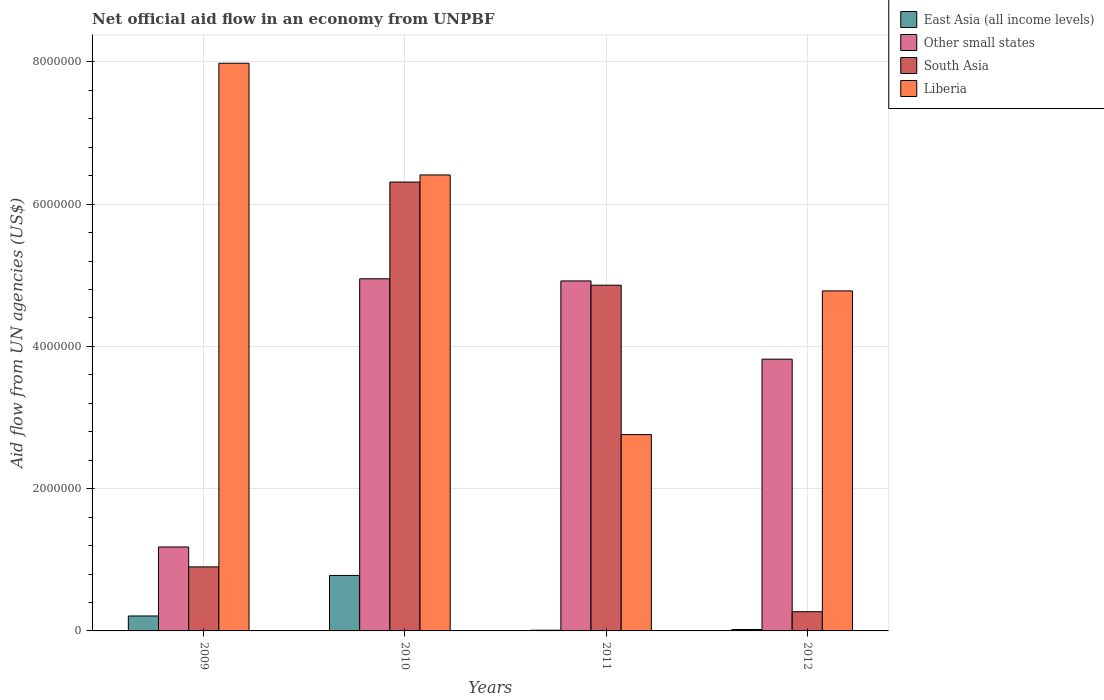How many bars are there on the 2nd tick from the left?
Keep it short and to the point. 4. What is the label of the 2nd group of bars from the left?
Give a very brief answer. 2010. In how many cases, is the number of bars for a given year not equal to the number of legend labels?
Provide a succinct answer. 0. What is the net official aid flow in Liberia in 2009?
Your answer should be compact. 7.98e+06. Across all years, what is the maximum net official aid flow in South Asia?
Keep it short and to the point. 6.31e+06. Across all years, what is the minimum net official aid flow in East Asia (all income levels)?
Your answer should be very brief. 10000. In which year was the net official aid flow in East Asia (all income levels) maximum?
Your answer should be compact. 2010. What is the total net official aid flow in East Asia (all income levels) in the graph?
Provide a short and direct response. 1.02e+06. What is the difference between the net official aid flow in Other small states in 2010 and that in 2012?
Your answer should be compact. 1.13e+06. What is the difference between the net official aid flow in East Asia (all income levels) in 2011 and the net official aid flow in Liberia in 2009?
Provide a short and direct response. -7.97e+06. What is the average net official aid flow in South Asia per year?
Your answer should be very brief. 3.08e+06. In the year 2010, what is the difference between the net official aid flow in East Asia (all income levels) and net official aid flow in Liberia?
Offer a very short reply. -5.63e+06. What is the ratio of the net official aid flow in Liberia in 2010 to that in 2012?
Your answer should be compact. 1.34. Is the net official aid flow in South Asia in 2011 less than that in 2012?
Offer a very short reply. No. What is the difference between the highest and the second highest net official aid flow in South Asia?
Your answer should be compact. 1.45e+06. What is the difference between the highest and the lowest net official aid flow in South Asia?
Keep it short and to the point. 6.04e+06. Is it the case that in every year, the sum of the net official aid flow in Other small states and net official aid flow in South Asia is greater than the sum of net official aid flow in Liberia and net official aid flow in East Asia (all income levels)?
Your answer should be compact. No. What does the 4th bar from the right in 2009 represents?
Offer a very short reply. East Asia (all income levels). Is it the case that in every year, the sum of the net official aid flow in Liberia and net official aid flow in South Asia is greater than the net official aid flow in East Asia (all income levels)?
Offer a very short reply. Yes. How many bars are there?
Ensure brevity in your answer.  16. Are all the bars in the graph horizontal?
Offer a terse response. No. How many years are there in the graph?
Your answer should be compact. 4. What is the difference between two consecutive major ticks on the Y-axis?
Make the answer very short. 2.00e+06. Are the values on the major ticks of Y-axis written in scientific E-notation?
Provide a short and direct response. No. Does the graph contain any zero values?
Your answer should be compact. No. How many legend labels are there?
Give a very brief answer. 4. How are the legend labels stacked?
Your answer should be very brief. Vertical. What is the title of the graph?
Your answer should be compact. Net official aid flow in an economy from UNPBF. Does "Nigeria" appear as one of the legend labels in the graph?
Your response must be concise. No. What is the label or title of the X-axis?
Your answer should be very brief. Years. What is the label or title of the Y-axis?
Make the answer very short. Aid flow from UN agencies (US$). What is the Aid flow from UN agencies (US$) in East Asia (all income levels) in 2009?
Provide a succinct answer. 2.10e+05. What is the Aid flow from UN agencies (US$) in Other small states in 2009?
Provide a short and direct response. 1.18e+06. What is the Aid flow from UN agencies (US$) in South Asia in 2009?
Your response must be concise. 9.00e+05. What is the Aid flow from UN agencies (US$) in Liberia in 2009?
Offer a very short reply. 7.98e+06. What is the Aid flow from UN agencies (US$) in East Asia (all income levels) in 2010?
Your answer should be compact. 7.80e+05. What is the Aid flow from UN agencies (US$) of Other small states in 2010?
Offer a very short reply. 4.95e+06. What is the Aid flow from UN agencies (US$) of South Asia in 2010?
Your response must be concise. 6.31e+06. What is the Aid flow from UN agencies (US$) in Liberia in 2010?
Your answer should be very brief. 6.41e+06. What is the Aid flow from UN agencies (US$) in East Asia (all income levels) in 2011?
Keep it short and to the point. 10000. What is the Aid flow from UN agencies (US$) in Other small states in 2011?
Provide a succinct answer. 4.92e+06. What is the Aid flow from UN agencies (US$) in South Asia in 2011?
Your response must be concise. 4.86e+06. What is the Aid flow from UN agencies (US$) of Liberia in 2011?
Give a very brief answer. 2.76e+06. What is the Aid flow from UN agencies (US$) of East Asia (all income levels) in 2012?
Provide a short and direct response. 2.00e+04. What is the Aid flow from UN agencies (US$) of Other small states in 2012?
Ensure brevity in your answer.  3.82e+06. What is the Aid flow from UN agencies (US$) in South Asia in 2012?
Provide a short and direct response. 2.70e+05. What is the Aid flow from UN agencies (US$) of Liberia in 2012?
Your answer should be compact. 4.78e+06. Across all years, what is the maximum Aid flow from UN agencies (US$) of East Asia (all income levels)?
Provide a short and direct response. 7.80e+05. Across all years, what is the maximum Aid flow from UN agencies (US$) in Other small states?
Offer a terse response. 4.95e+06. Across all years, what is the maximum Aid flow from UN agencies (US$) of South Asia?
Keep it short and to the point. 6.31e+06. Across all years, what is the maximum Aid flow from UN agencies (US$) of Liberia?
Offer a very short reply. 7.98e+06. Across all years, what is the minimum Aid flow from UN agencies (US$) in East Asia (all income levels)?
Your answer should be very brief. 10000. Across all years, what is the minimum Aid flow from UN agencies (US$) in Other small states?
Provide a succinct answer. 1.18e+06. Across all years, what is the minimum Aid flow from UN agencies (US$) of South Asia?
Ensure brevity in your answer.  2.70e+05. Across all years, what is the minimum Aid flow from UN agencies (US$) in Liberia?
Give a very brief answer. 2.76e+06. What is the total Aid flow from UN agencies (US$) in East Asia (all income levels) in the graph?
Keep it short and to the point. 1.02e+06. What is the total Aid flow from UN agencies (US$) of Other small states in the graph?
Provide a short and direct response. 1.49e+07. What is the total Aid flow from UN agencies (US$) of South Asia in the graph?
Keep it short and to the point. 1.23e+07. What is the total Aid flow from UN agencies (US$) of Liberia in the graph?
Keep it short and to the point. 2.19e+07. What is the difference between the Aid flow from UN agencies (US$) in East Asia (all income levels) in 2009 and that in 2010?
Your answer should be compact. -5.70e+05. What is the difference between the Aid flow from UN agencies (US$) in Other small states in 2009 and that in 2010?
Provide a short and direct response. -3.77e+06. What is the difference between the Aid flow from UN agencies (US$) of South Asia in 2009 and that in 2010?
Provide a short and direct response. -5.41e+06. What is the difference between the Aid flow from UN agencies (US$) in Liberia in 2009 and that in 2010?
Your answer should be very brief. 1.57e+06. What is the difference between the Aid flow from UN agencies (US$) in East Asia (all income levels) in 2009 and that in 2011?
Ensure brevity in your answer.  2.00e+05. What is the difference between the Aid flow from UN agencies (US$) of Other small states in 2009 and that in 2011?
Your answer should be very brief. -3.74e+06. What is the difference between the Aid flow from UN agencies (US$) in South Asia in 2009 and that in 2011?
Offer a terse response. -3.96e+06. What is the difference between the Aid flow from UN agencies (US$) of Liberia in 2009 and that in 2011?
Your answer should be compact. 5.22e+06. What is the difference between the Aid flow from UN agencies (US$) in Other small states in 2009 and that in 2012?
Ensure brevity in your answer.  -2.64e+06. What is the difference between the Aid flow from UN agencies (US$) in South Asia in 2009 and that in 2012?
Your response must be concise. 6.30e+05. What is the difference between the Aid flow from UN agencies (US$) of Liberia in 2009 and that in 2012?
Offer a very short reply. 3.20e+06. What is the difference between the Aid flow from UN agencies (US$) in East Asia (all income levels) in 2010 and that in 2011?
Your response must be concise. 7.70e+05. What is the difference between the Aid flow from UN agencies (US$) of Other small states in 2010 and that in 2011?
Keep it short and to the point. 3.00e+04. What is the difference between the Aid flow from UN agencies (US$) of South Asia in 2010 and that in 2011?
Offer a very short reply. 1.45e+06. What is the difference between the Aid flow from UN agencies (US$) in Liberia in 2010 and that in 2011?
Provide a short and direct response. 3.65e+06. What is the difference between the Aid flow from UN agencies (US$) of East Asia (all income levels) in 2010 and that in 2012?
Ensure brevity in your answer.  7.60e+05. What is the difference between the Aid flow from UN agencies (US$) of Other small states in 2010 and that in 2012?
Your response must be concise. 1.13e+06. What is the difference between the Aid flow from UN agencies (US$) of South Asia in 2010 and that in 2012?
Keep it short and to the point. 6.04e+06. What is the difference between the Aid flow from UN agencies (US$) of Liberia in 2010 and that in 2012?
Offer a terse response. 1.63e+06. What is the difference between the Aid flow from UN agencies (US$) in Other small states in 2011 and that in 2012?
Keep it short and to the point. 1.10e+06. What is the difference between the Aid flow from UN agencies (US$) of South Asia in 2011 and that in 2012?
Your answer should be very brief. 4.59e+06. What is the difference between the Aid flow from UN agencies (US$) in Liberia in 2011 and that in 2012?
Make the answer very short. -2.02e+06. What is the difference between the Aid flow from UN agencies (US$) of East Asia (all income levels) in 2009 and the Aid flow from UN agencies (US$) of Other small states in 2010?
Provide a succinct answer. -4.74e+06. What is the difference between the Aid flow from UN agencies (US$) of East Asia (all income levels) in 2009 and the Aid flow from UN agencies (US$) of South Asia in 2010?
Your answer should be very brief. -6.10e+06. What is the difference between the Aid flow from UN agencies (US$) in East Asia (all income levels) in 2009 and the Aid flow from UN agencies (US$) in Liberia in 2010?
Provide a short and direct response. -6.20e+06. What is the difference between the Aid flow from UN agencies (US$) in Other small states in 2009 and the Aid flow from UN agencies (US$) in South Asia in 2010?
Give a very brief answer. -5.13e+06. What is the difference between the Aid flow from UN agencies (US$) of Other small states in 2009 and the Aid flow from UN agencies (US$) of Liberia in 2010?
Provide a short and direct response. -5.23e+06. What is the difference between the Aid flow from UN agencies (US$) of South Asia in 2009 and the Aid flow from UN agencies (US$) of Liberia in 2010?
Provide a succinct answer. -5.51e+06. What is the difference between the Aid flow from UN agencies (US$) in East Asia (all income levels) in 2009 and the Aid flow from UN agencies (US$) in Other small states in 2011?
Make the answer very short. -4.71e+06. What is the difference between the Aid flow from UN agencies (US$) in East Asia (all income levels) in 2009 and the Aid flow from UN agencies (US$) in South Asia in 2011?
Your answer should be compact. -4.65e+06. What is the difference between the Aid flow from UN agencies (US$) of East Asia (all income levels) in 2009 and the Aid flow from UN agencies (US$) of Liberia in 2011?
Provide a succinct answer. -2.55e+06. What is the difference between the Aid flow from UN agencies (US$) of Other small states in 2009 and the Aid flow from UN agencies (US$) of South Asia in 2011?
Give a very brief answer. -3.68e+06. What is the difference between the Aid flow from UN agencies (US$) of Other small states in 2009 and the Aid flow from UN agencies (US$) of Liberia in 2011?
Your answer should be compact. -1.58e+06. What is the difference between the Aid flow from UN agencies (US$) in South Asia in 2009 and the Aid flow from UN agencies (US$) in Liberia in 2011?
Your answer should be compact. -1.86e+06. What is the difference between the Aid flow from UN agencies (US$) of East Asia (all income levels) in 2009 and the Aid flow from UN agencies (US$) of Other small states in 2012?
Offer a very short reply. -3.61e+06. What is the difference between the Aid flow from UN agencies (US$) in East Asia (all income levels) in 2009 and the Aid flow from UN agencies (US$) in Liberia in 2012?
Your answer should be compact. -4.57e+06. What is the difference between the Aid flow from UN agencies (US$) in Other small states in 2009 and the Aid flow from UN agencies (US$) in South Asia in 2012?
Keep it short and to the point. 9.10e+05. What is the difference between the Aid flow from UN agencies (US$) of Other small states in 2009 and the Aid flow from UN agencies (US$) of Liberia in 2012?
Offer a very short reply. -3.60e+06. What is the difference between the Aid flow from UN agencies (US$) of South Asia in 2009 and the Aid flow from UN agencies (US$) of Liberia in 2012?
Keep it short and to the point. -3.88e+06. What is the difference between the Aid flow from UN agencies (US$) in East Asia (all income levels) in 2010 and the Aid flow from UN agencies (US$) in Other small states in 2011?
Keep it short and to the point. -4.14e+06. What is the difference between the Aid flow from UN agencies (US$) of East Asia (all income levels) in 2010 and the Aid flow from UN agencies (US$) of South Asia in 2011?
Offer a terse response. -4.08e+06. What is the difference between the Aid flow from UN agencies (US$) in East Asia (all income levels) in 2010 and the Aid flow from UN agencies (US$) in Liberia in 2011?
Give a very brief answer. -1.98e+06. What is the difference between the Aid flow from UN agencies (US$) of Other small states in 2010 and the Aid flow from UN agencies (US$) of South Asia in 2011?
Offer a terse response. 9.00e+04. What is the difference between the Aid flow from UN agencies (US$) in Other small states in 2010 and the Aid flow from UN agencies (US$) in Liberia in 2011?
Offer a terse response. 2.19e+06. What is the difference between the Aid flow from UN agencies (US$) in South Asia in 2010 and the Aid flow from UN agencies (US$) in Liberia in 2011?
Provide a succinct answer. 3.55e+06. What is the difference between the Aid flow from UN agencies (US$) of East Asia (all income levels) in 2010 and the Aid flow from UN agencies (US$) of Other small states in 2012?
Provide a succinct answer. -3.04e+06. What is the difference between the Aid flow from UN agencies (US$) in East Asia (all income levels) in 2010 and the Aid flow from UN agencies (US$) in South Asia in 2012?
Provide a succinct answer. 5.10e+05. What is the difference between the Aid flow from UN agencies (US$) in East Asia (all income levels) in 2010 and the Aid flow from UN agencies (US$) in Liberia in 2012?
Your answer should be compact. -4.00e+06. What is the difference between the Aid flow from UN agencies (US$) of Other small states in 2010 and the Aid flow from UN agencies (US$) of South Asia in 2012?
Provide a short and direct response. 4.68e+06. What is the difference between the Aid flow from UN agencies (US$) in Other small states in 2010 and the Aid flow from UN agencies (US$) in Liberia in 2012?
Your answer should be very brief. 1.70e+05. What is the difference between the Aid flow from UN agencies (US$) in South Asia in 2010 and the Aid flow from UN agencies (US$) in Liberia in 2012?
Your response must be concise. 1.53e+06. What is the difference between the Aid flow from UN agencies (US$) in East Asia (all income levels) in 2011 and the Aid flow from UN agencies (US$) in Other small states in 2012?
Keep it short and to the point. -3.81e+06. What is the difference between the Aid flow from UN agencies (US$) in East Asia (all income levels) in 2011 and the Aid flow from UN agencies (US$) in Liberia in 2012?
Offer a terse response. -4.77e+06. What is the difference between the Aid flow from UN agencies (US$) of Other small states in 2011 and the Aid flow from UN agencies (US$) of South Asia in 2012?
Give a very brief answer. 4.65e+06. What is the difference between the Aid flow from UN agencies (US$) of Other small states in 2011 and the Aid flow from UN agencies (US$) of Liberia in 2012?
Give a very brief answer. 1.40e+05. What is the difference between the Aid flow from UN agencies (US$) in South Asia in 2011 and the Aid flow from UN agencies (US$) in Liberia in 2012?
Make the answer very short. 8.00e+04. What is the average Aid flow from UN agencies (US$) of East Asia (all income levels) per year?
Your response must be concise. 2.55e+05. What is the average Aid flow from UN agencies (US$) in Other small states per year?
Offer a very short reply. 3.72e+06. What is the average Aid flow from UN agencies (US$) in South Asia per year?
Your answer should be very brief. 3.08e+06. What is the average Aid flow from UN agencies (US$) in Liberia per year?
Give a very brief answer. 5.48e+06. In the year 2009, what is the difference between the Aid flow from UN agencies (US$) of East Asia (all income levels) and Aid flow from UN agencies (US$) of Other small states?
Ensure brevity in your answer.  -9.70e+05. In the year 2009, what is the difference between the Aid flow from UN agencies (US$) in East Asia (all income levels) and Aid flow from UN agencies (US$) in South Asia?
Your answer should be compact. -6.90e+05. In the year 2009, what is the difference between the Aid flow from UN agencies (US$) in East Asia (all income levels) and Aid flow from UN agencies (US$) in Liberia?
Ensure brevity in your answer.  -7.77e+06. In the year 2009, what is the difference between the Aid flow from UN agencies (US$) in Other small states and Aid flow from UN agencies (US$) in South Asia?
Make the answer very short. 2.80e+05. In the year 2009, what is the difference between the Aid flow from UN agencies (US$) of Other small states and Aid flow from UN agencies (US$) of Liberia?
Keep it short and to the point. -6.80e+06. In the year 2009, what is the difference between the Aid flow from UN agencies (US$) of South Asia and Aid flow from UN agencies (US$) of Liberia?
Your response must be concise. -7.08e+06. In the year 2010, what is the difference between the Aid flow from UN agencies (US$) in East Asia (all income levels) and Aid flow from UN agencies (US$) in Other small states?
Offer a very short reply. -4.17e+06. In the year 2010, what is the difference between the Aid flow from UN agencies (US$) in East Asia (all income levels) and Aid flow from UN agencies (US$) in South Asia?
Make the answer very short. -5.53e+06. In the year 2010, what is the difference between the Aid flow from UN agencies (US$) of East Asia (all income levels) and Aid flow from UN agencies (US$) of Liberia?
Provide a short and direct response. -5.63e+06. In the year 2010, what is the difference between the Aid flow from UN agencies (US$) of Other small states and Aid flow from UN agencies (US$) of South Asia?
Your answer should be compact. -1.36e+06. In the year 2010, what is the difference between the Aid flow from UN agencies (US$) of Other small states and Aid flow from UN agencies (US$) of Liberia?
Your answer should be very brief. -1.46e+06. In the year 2011, what is the difference between the Aid flow from UN agencies (US$) of East Asia (all income levels) and Aid flow from UN agencies (US$) of Other small states?
Offer a terse response. -4.91e+06. In the year 2011, what is the difference between the Aid flow from UN agencies (US$) of East Asia (all income levels) and Aid flow from UN agencies (US$) of South Asia?
Keep it short and to the point. -4.85e+06. In the year 2011, what is the difference between the Aid flow from UN agencies (US$) of East Asia (all income levels) and Aid flow from UN agencies (US$) of Liberia?
Offer a terse response. -2.75e+06. In the year 2011, what is the difference between the Aid flow from UN agencies (US$) of Other small states and Aid flow from UN agencies (US$) of Liberia?
Ensure brevity in your answer.  2.16e+06. In the year 2011, what is the difference between the Aid flow from UN agencies (US$) of South Asia and Aid flow from UN agencies (US$) of Liberia?
Make the answer very short. 2.10e+06. In the year 2012, what is the difference between the Aid flow from UN agencies (US$) in East Asia (all income levels) and Aid flow from UN agencies (US$) in Other small states?
Your response must be concise. -3.80e+06. In the year 2012, what is the difference between the Aid flow from UN agencies (US$) of East Asia (all income levels) and Aid flow from UN agencies (US$) of South Asia?
Make the answer very short. -2.50e+05. In the year 2012, what is the difference between the Aid flow from UN agencies (US$) in East Asia (all income levels) and Aid flow from UN agencies (US$) in Liberia?
Your answer should be very brief. -4.76e+06. In the year 2012, what is the difference between the Aid flow from UN agencies (US$) of Other small states and Aid flow from UN agencies (US$) of South Asia?
Keep it short and to the point. 3.55e+06. In the year 2012, what is the difference between the Aid flow from UN agencies (US$) of Other small states and Aid flow from UN agencies (US$) of Liberia?
Offer a very short reply. -9.60e+05. In the year 2012, what is the difference between the Aid flow from UN agencies (US$) of South Asia and Aid flow from UN agencies (US$) of Liberia?
Your answer should be compact. -4.51e+06. What is the ratio of the Aid flow from UN agencies (US$) of East Asia (all income levels) in 2009 to that in 2010?
Keep it short and to the point. 0.27. What is the ratio of the Aid flow from UN agencies (US$) in Other small states in 2009 to that in 2010?
Your answer should be very brief. 0.24. What is the ratio of the Aid flow from UN agencies (US$) of South Asia in 2009 to that in 2010?
Offer a terse response. 0.14. What is the ratio of the Aid flow from UN agencies (US$) in Liberia in 2009 to that in 2010?
Ensure brevity in your answer.  1.24. What is the ratio of the Aid flow from UN agencies (US$) in Other small states in 2009 to that in 2011?
Provide a short and direct response. 0.24. What is the ratio of the Aid flow from UN agencies (US$) of South Asia in 2009 to that in 2011?
Your response must be concise. 0.19. What is the ratio of the Aid flow from UN agencies (US$) of Liberia in 2009 to that in 2011?
Keep it short and to the point. 2.89. What is the ratio of the Aid flow from UN agencies (US$) of Other small states in 2009 to that in 2012?
Offer a very short reply. 0.31. What is the ratio of the Aid flow from UN agencies (US$) of Liberia in 2009 to that in 2012?
Make the answer very short. 1.67. What is the ratio of the Aid flow from UN agencies (US$) of South Asia in 2010 to that in 2011?
Ensure brevity in your answer.  1.3. What is the ratio of the Aid flow from UN agencies (US$) in Liberia in 2010 to that in 2011?
Your response must be concise. 2.32. What is the ratio of the Aid flow from UN agencies (US$) in East Asia (all income levels) in 2010 to that in 2012?
Offer a terse response. 39. What is the ratio of the Aid flow from UN agencies (US$) in Other small states in 2010 to that in 2012?
Ensure brevity in your answer.  1.3. What is the ratio of the Aid flow from UN agencies (US$) in South Asia in 2010 to that in 2012?
Make the answer very short. 23.37. What is the ratio of the Aid flow from UN agencies (US$) in Liberia in 2010 to that in 2012?
Make the answer very short. 1.34. What is the ratio of the Aid flow from UN agencies (US$) in Other small states in 2011 to that in 2012?
Your response must be concise. 1.29. What is the ratio of the Aid flow from UN agencies (US$) in South Asia in 2011 to that in 2012?
Provide a short and direct response. 18. What is the ratio of the Aid flow from UN agencies (US$) in Liberia in 2011 to that in 2012?
Offer a very short reply. 0.58. What is the difference between the highest and the second highest Aid flow from UN agencies (US$) in East Asia (all income levels)?
Your answer should be compact. 5.70e+05. What is the difference between the highest and the second highest Aid flow from UN agencies (US$) of Other small states?
Offer a very short reply. 3.00e+04. What is the difference between the highest and the second highest Aid flow from UN agencies (US$) of South Asia?
Make the answer very short. 1.45e+06. What is the difference between the highest and the second highest Aid flow from UN agencies (US$) of Liberia?
Ensure brevity in your answer.  1.57e+06. What is the difference between the highest and the lowest Aid flow from UN agencies (US$) in East Asia (all income levels)?
Ensure brevity in your answer.  7.70e+05. What is the difference between the highest and the lowest Aid flow from UN agencies (US$) of Other small states?
Offer a terse response. 3.77e+06. What is the difference between the highest and the lowest Aid flow from UN agencies (US$) of South Asia?
Your answer should be very brief. 6.04e+06. What is the difference between the highest and the lowest Aid flow from UN agencies (US$) of Liberia?
Keep it short and to the point. 5.22e+06. 